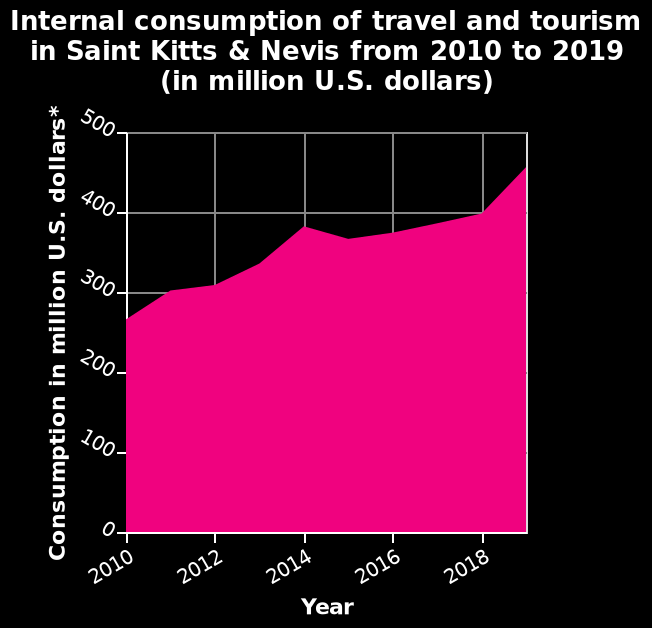<image>
What does the y-axis represent?  The y-axis represents the consumption in million U.S. dollars. please summary the statistics and relations of the chart More money has been spent on internal consumption of travel and tourism over the period. It is now at the peak. The increase has not been the same every year and in one year there was a slight drop. However overall it has been an increased spend. Has there been a decrease in spending on internal consumption of travel and tourism? Yes, there was a slight drop in spending on internal consumption of travel and tourism in one year, but overall there has been an increased spend. 